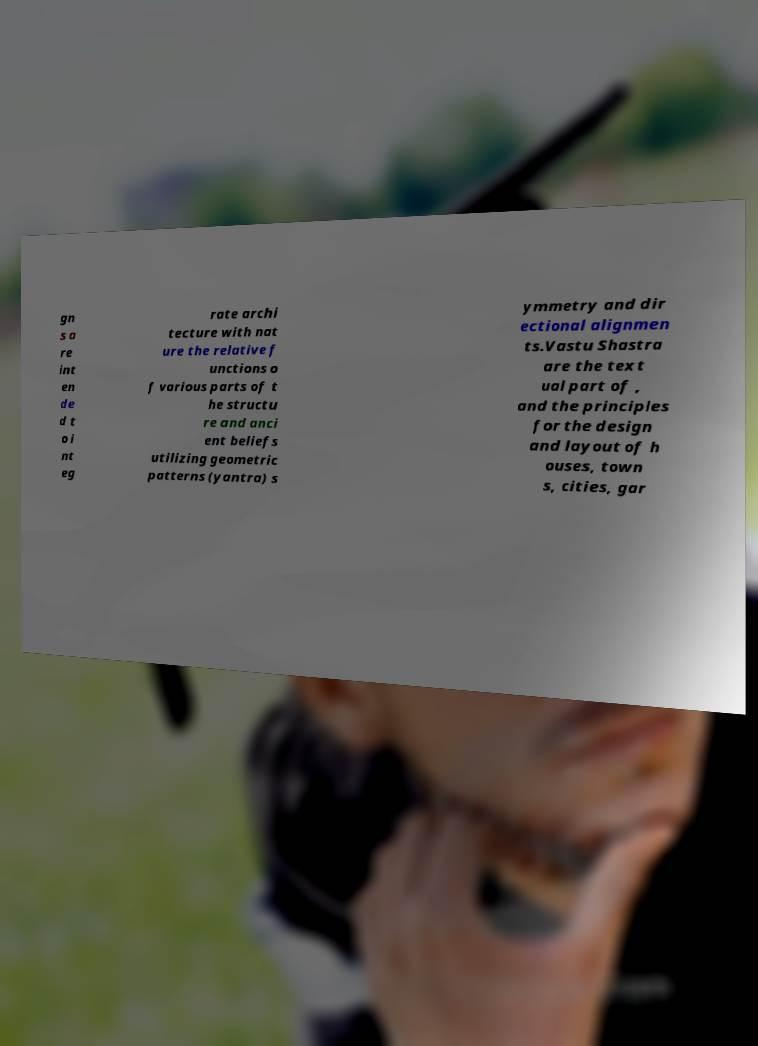What messages or text are displayed in this image? I need them in a readable, typed format. gn s a re int en de d t o i nt eg rate archi tecture with nat ure the relative f unctions o f various parts of t he structu re and anci ent beliefs utilizing geometric patterns (yantra) s ymmetry and dir ectional alignmen ts.Vastu Shastra are the text ual part of , and the principles for the design and layout of h ouses, town s, cities, gar 